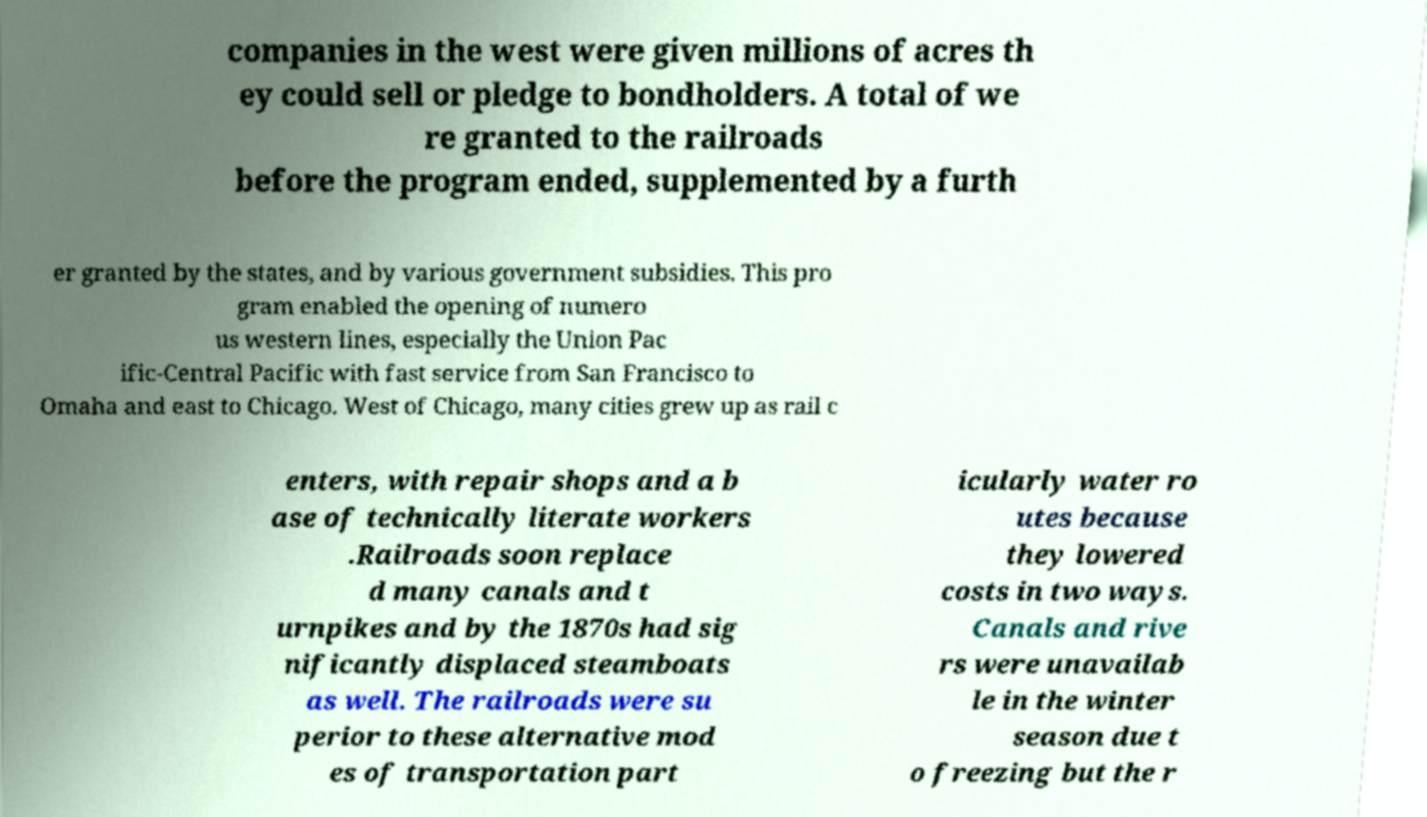Please identify and transcribe the text found in this image. companies in the west were given millions of acres th ey could sell or pledge to bondholders. A total of we re granted to the railroads before the program ended, supplemented by a furth er granted by the states, and by various government subsidies. This pro gram enabled the opening of numero us western lines, especially the Union Pac ific-Central Pacific with fast service from San Francisco to Omaha and east to Chicago. West of Chicago, many cities grew up as rail c enters, with repair shops and a b ase of technically literate workers .Railroads soon replace d many canals and t urnpikes and by the 1870s had sig nificantly displaced steamboats as well. The railroads were su perior to these alternative mod es of transportation part icularly water ro utes because they lowered costs in two ways. Canals and rive rs were unavailab le in the winter season due t o freezing but the r 